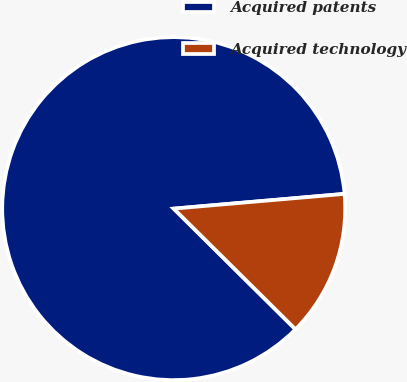Convert chart. <chart><loc_0><loc_0><loc_500><loc_500><pie_chart><fcel>Acquired patents<fcel>Acquired technology<nl><fcel>86.2%<fcel>13.8%<nl></chart> 